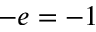<formula> <loc_0><loc_0><loc_500><loc_500>- e = - 1</formula> 